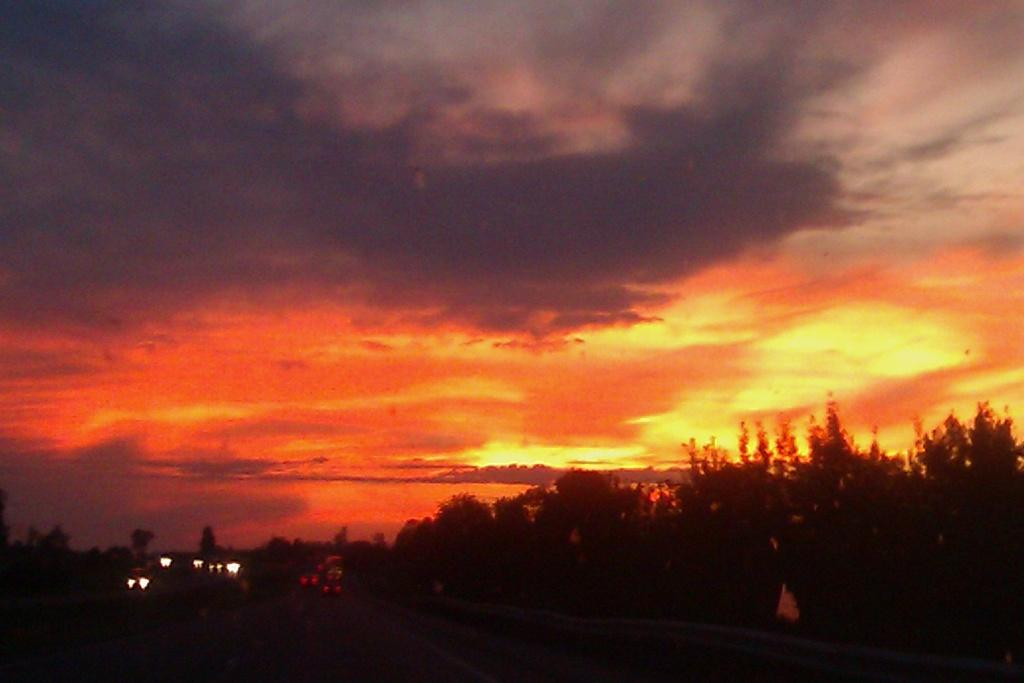What type of natural elements can be seen in the image? There are trees in the image. What artificial elements can be seen in the image? There are lights in the image. How would you describe the colors of the sky in the image? The sky has a combination of white, black, orange, and yellow colors. Can you tell me how many goats are grazing under the trees in the image? There are no goats present in the image; it only features trees and lights. What type of calculator can be seen on the ground near the lights? There is no calculator present in the image; it only features trees and lights. 